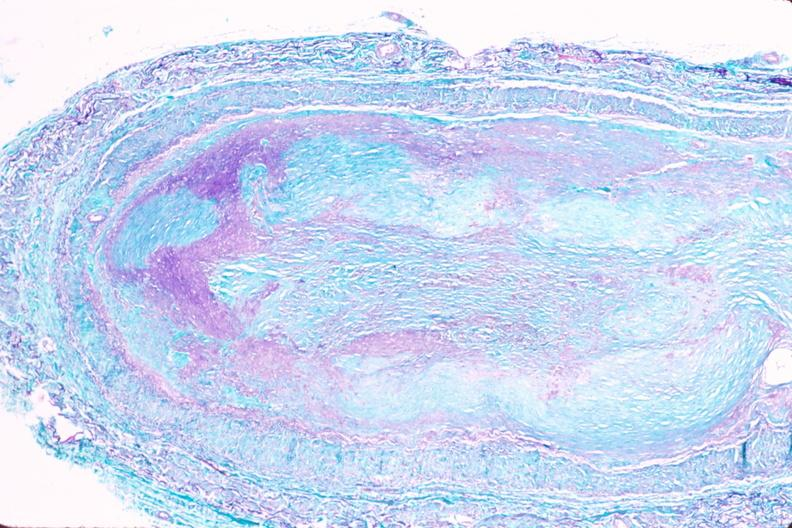s case of peritonitis slide present?
Answer the question using a single word or phrase. No 